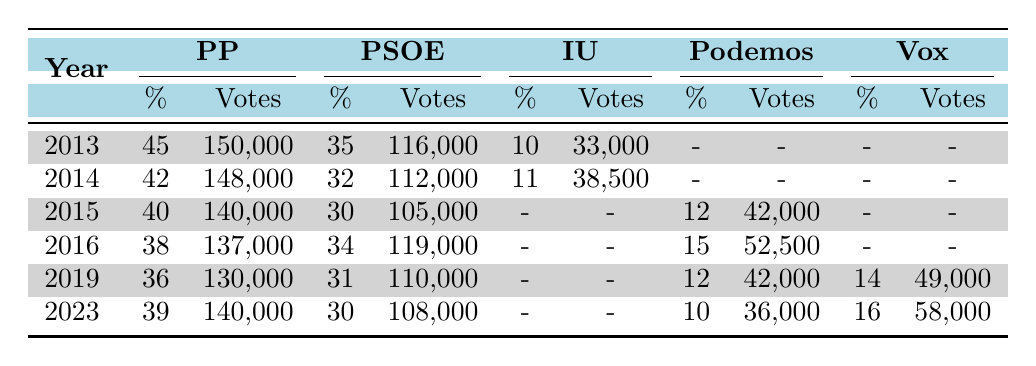What was the percentage of votes for PP in 2016? In the row for the year 2016 under the PP (Partido Popular) column, the percentage is listed as 38%.
Answer: 38% How many votes did PSOE receive in 2019? In the row for the year 2019 under the PSOE column, the votes are listed as 110,000.
Answer: 110,000 Did IU receive more votes than Podemos in 2015? In the year 2015, IU received no votes (indicated by a dash), while Podemos received 42,000 votes, indicating that Podemos had more votes.
Answer: No What is the total number of votes for PP from 2013 to 2023? Adding up the votes for PP from each year gives: 150,000 (2013) + 148,000 (2014) + 140,000 (2015) + 137,000 (2016) + 130,000 (2019) + 140,000 (2023) = 845,000 votes in total.
Answer: 845,000 Did the percentage of votes for Vox increase from 2019 to 2023? In 2019, Vox received 14%, while in 2023, they received 16%. This indicates that the percentage of votes for Vox increased.
Answer: Yes What is the average percentage of votes for PSOE over the years listed? The percentages for PSOE are 35 (2013), 32 (2014), 30 (2015), 34 (2016), 31 (2019), and 30 (2023). The sum is 35 + 32 + 30 + 34 + 31 + 30 = 192. Dividing by 6 gives us an average of 32%.
Answer: 32% In which year did Podemos first appear in the voting data? Podemos appears in the voting data starting from the year 2015, as indicated in the table.
Answer: 2015 What was the difference in votes between PP and Vox in 2023? In 2023, PP received 140,000 votes and Vox received 58,000 votes. The difference is 140,000 - 58,000 = 82,000 votes in favor of PP.
Answer: 82,000 What was the percentage of votes for Other parties in 2014? In 2014, the percentage of votes for Other parties in the table is listed as 15%.
Answer: 15% 